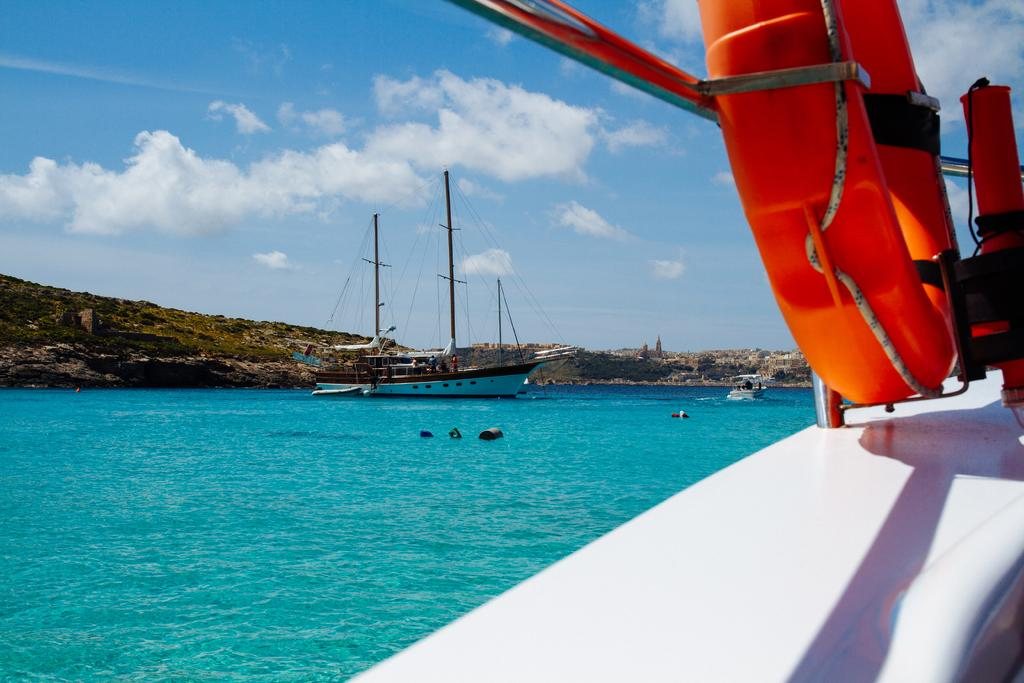What is the location of the image? The image is captured from a ship. What is the ship's position in relation to the water? The ship is on the water surface. Are there any other ships visible in the image? Yes, there are two other ships in the distance. What type of surface can be seen behind the other ships? There is a stone surface behind the other ships. What type of weather can be seen in the image? The provided facts do not mention any specific weather conditions in the image. 